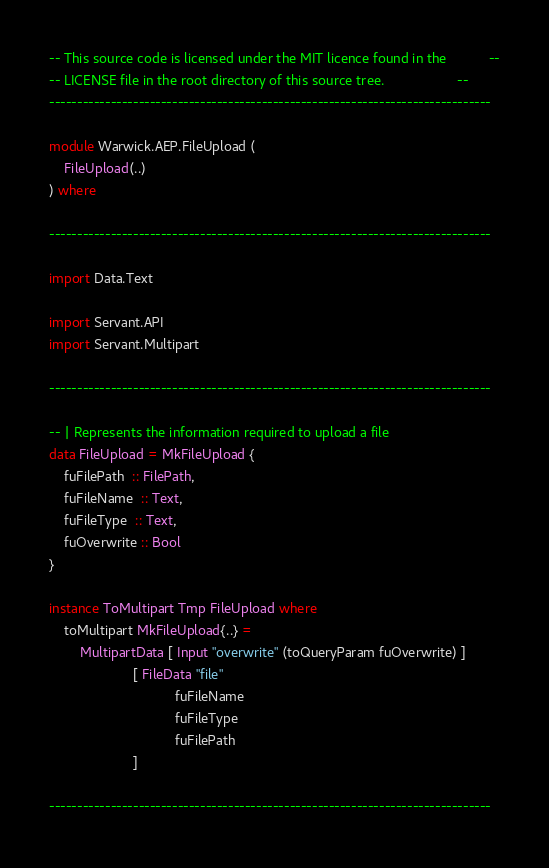<code> <loc_0><loc_0><loc_500><loc_500><_Haskell_>-- This source code is licensed under the MIT licence found in the           --
-- LICENSE file in the root directory of this source tree.                   --
-------------------------------------------------------------------------------

module Warwick.AEP.FileUpload (
    FileUpload(..)
) where

-------------------------------------------------------------------------------

import Data.Text

import Servant.API
import Servant.Multipart

-------------------------------------------------------------------------------

-- | Represents the information required to upload a file
data FileUpload = MkFileUpload {
    fuFilePath  :: FilePath,
    fuFileName  :: Text,
    fuFileType  :: Text,
    fuOverwrite :: Bool
}

instance ToMultipart Tmp FileUpload where
    toMultipart MkFileUpload{..} =
        MultipartData [ Input "overwrite" (toQueryParam fuOverwrite) ]
                      [ FileData "file"
                                 fuFileName
                                 fuFileType
                                 fuFilePath
                      ]

-------------------------------------------------------------------------------
</code> 